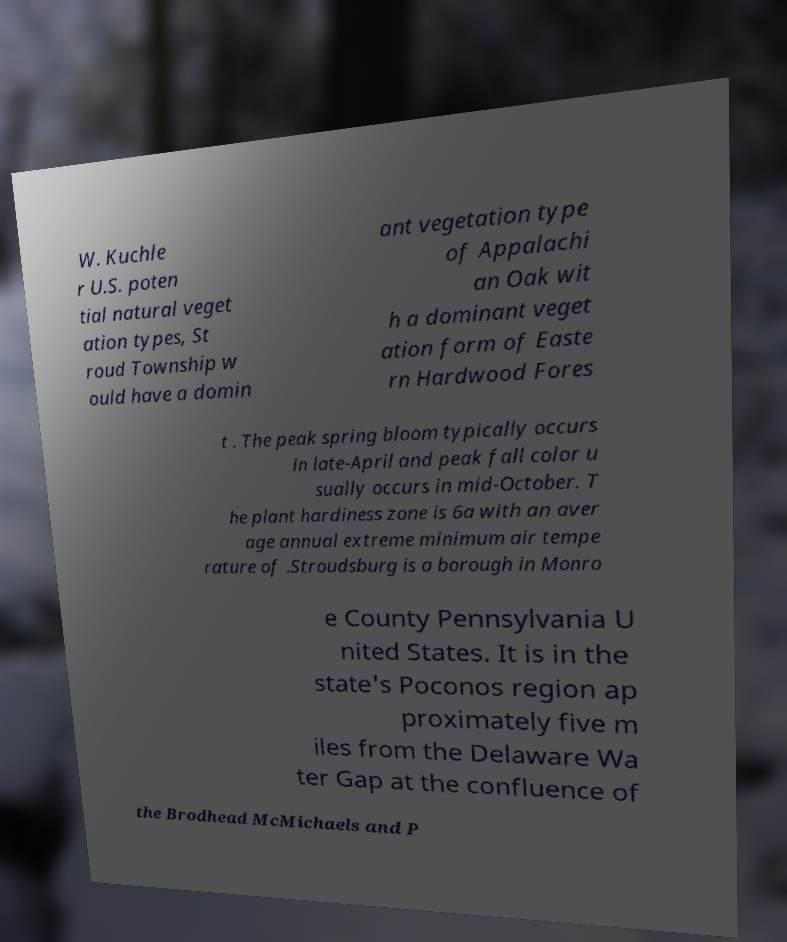Could you assist in decoding the text presented in this image and type it out clearly? W. Kuchle r U.S. poten tial natural veget ation types, St roud Township w ould have a domin ant vegetation type of Appalachi an Oak wit h a dominant veget ation form of Easte rn Hardwood Fores t . The peak spring bloom typically occurs in late-April and peak fall color u sually occurs in mid-October. T he plant hardiness zone is 6a with an aver age annual extreme minimum air tempe rature of .Stroudsburg is a borough in Monro e County Pennsylvania U nited States. It is in the state's Poconos region ap proximately five m iles from the Delaware Wa ter Gap at the confluence of the Brodhead McMichaels and P 